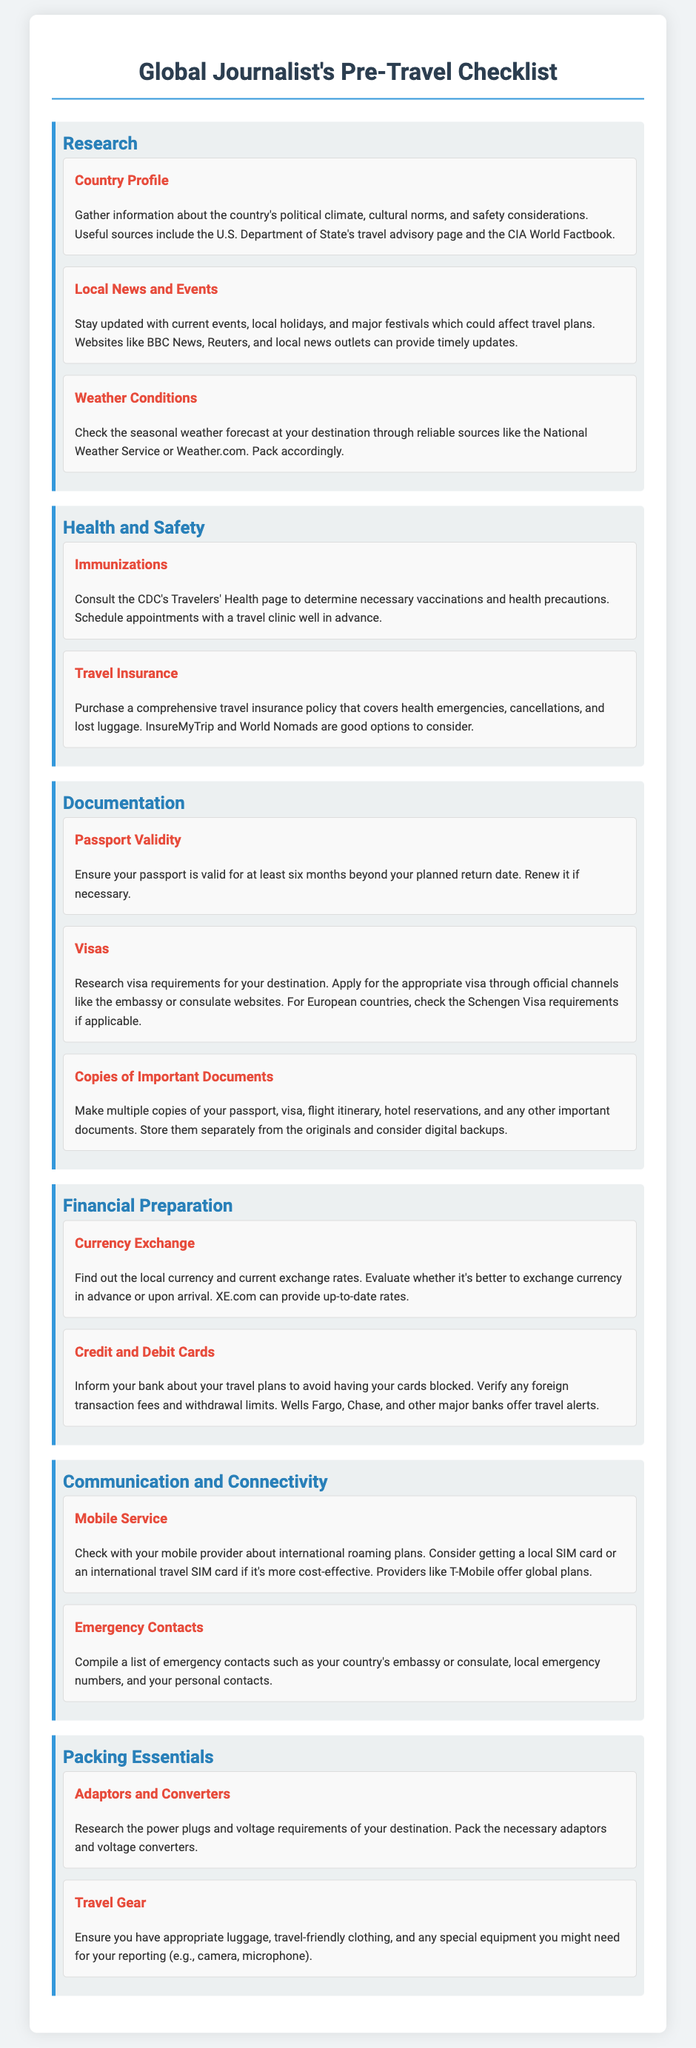What are some recommended sources for gathering country profiles? The document suggests the U.S. Department of State's travel advisory page and the CIA World Factbook as useful sources for country profiles.
Answer: U.S. Department of State's travel advisory page and the CIA World Factbook What is suggested to be checked according to the weather conditions section? It is recommended to check the seasonal weather forecast at your destination through reliable sources like the National Weather Service or Weather.com.
Answer: Seasonal weather forecast Which organization’s page should be consulted for immunizations? The document advises to consult the CDC's Travelers' Health page for necessary vaccinations and health precautions.
Answer: CDC's Travelers' Health page How long must a passport be valid beyond the planned return date? The document states that a passport must be valid for at least six months beyond the planned return date.
Answer: Six months What should be made multiple copies of according to the documentation section? The document lists passport, visa, flight itinerary, hotel reservations, and any other important documents as items to make multiple copies of.
Answer: Passport, visa, flight itinerary, hotel reservations According to the currency exchange advice, what should be evaluated? It advises evaluating whether it’s better to exchange currency in advance or upon arrival.
Answer: Currency exchange options What type of cards should be informed about travel plans to avoid blocks? The document mentions informing credit and debit cards about travel plans to prevent them from being blocked.
Answer: Credit and debit cards Which local service is recommended for mobile connectivity? The document suggests checking with your mobile provider about international roaming plans for mobile service.
Answer: Mobile provider 